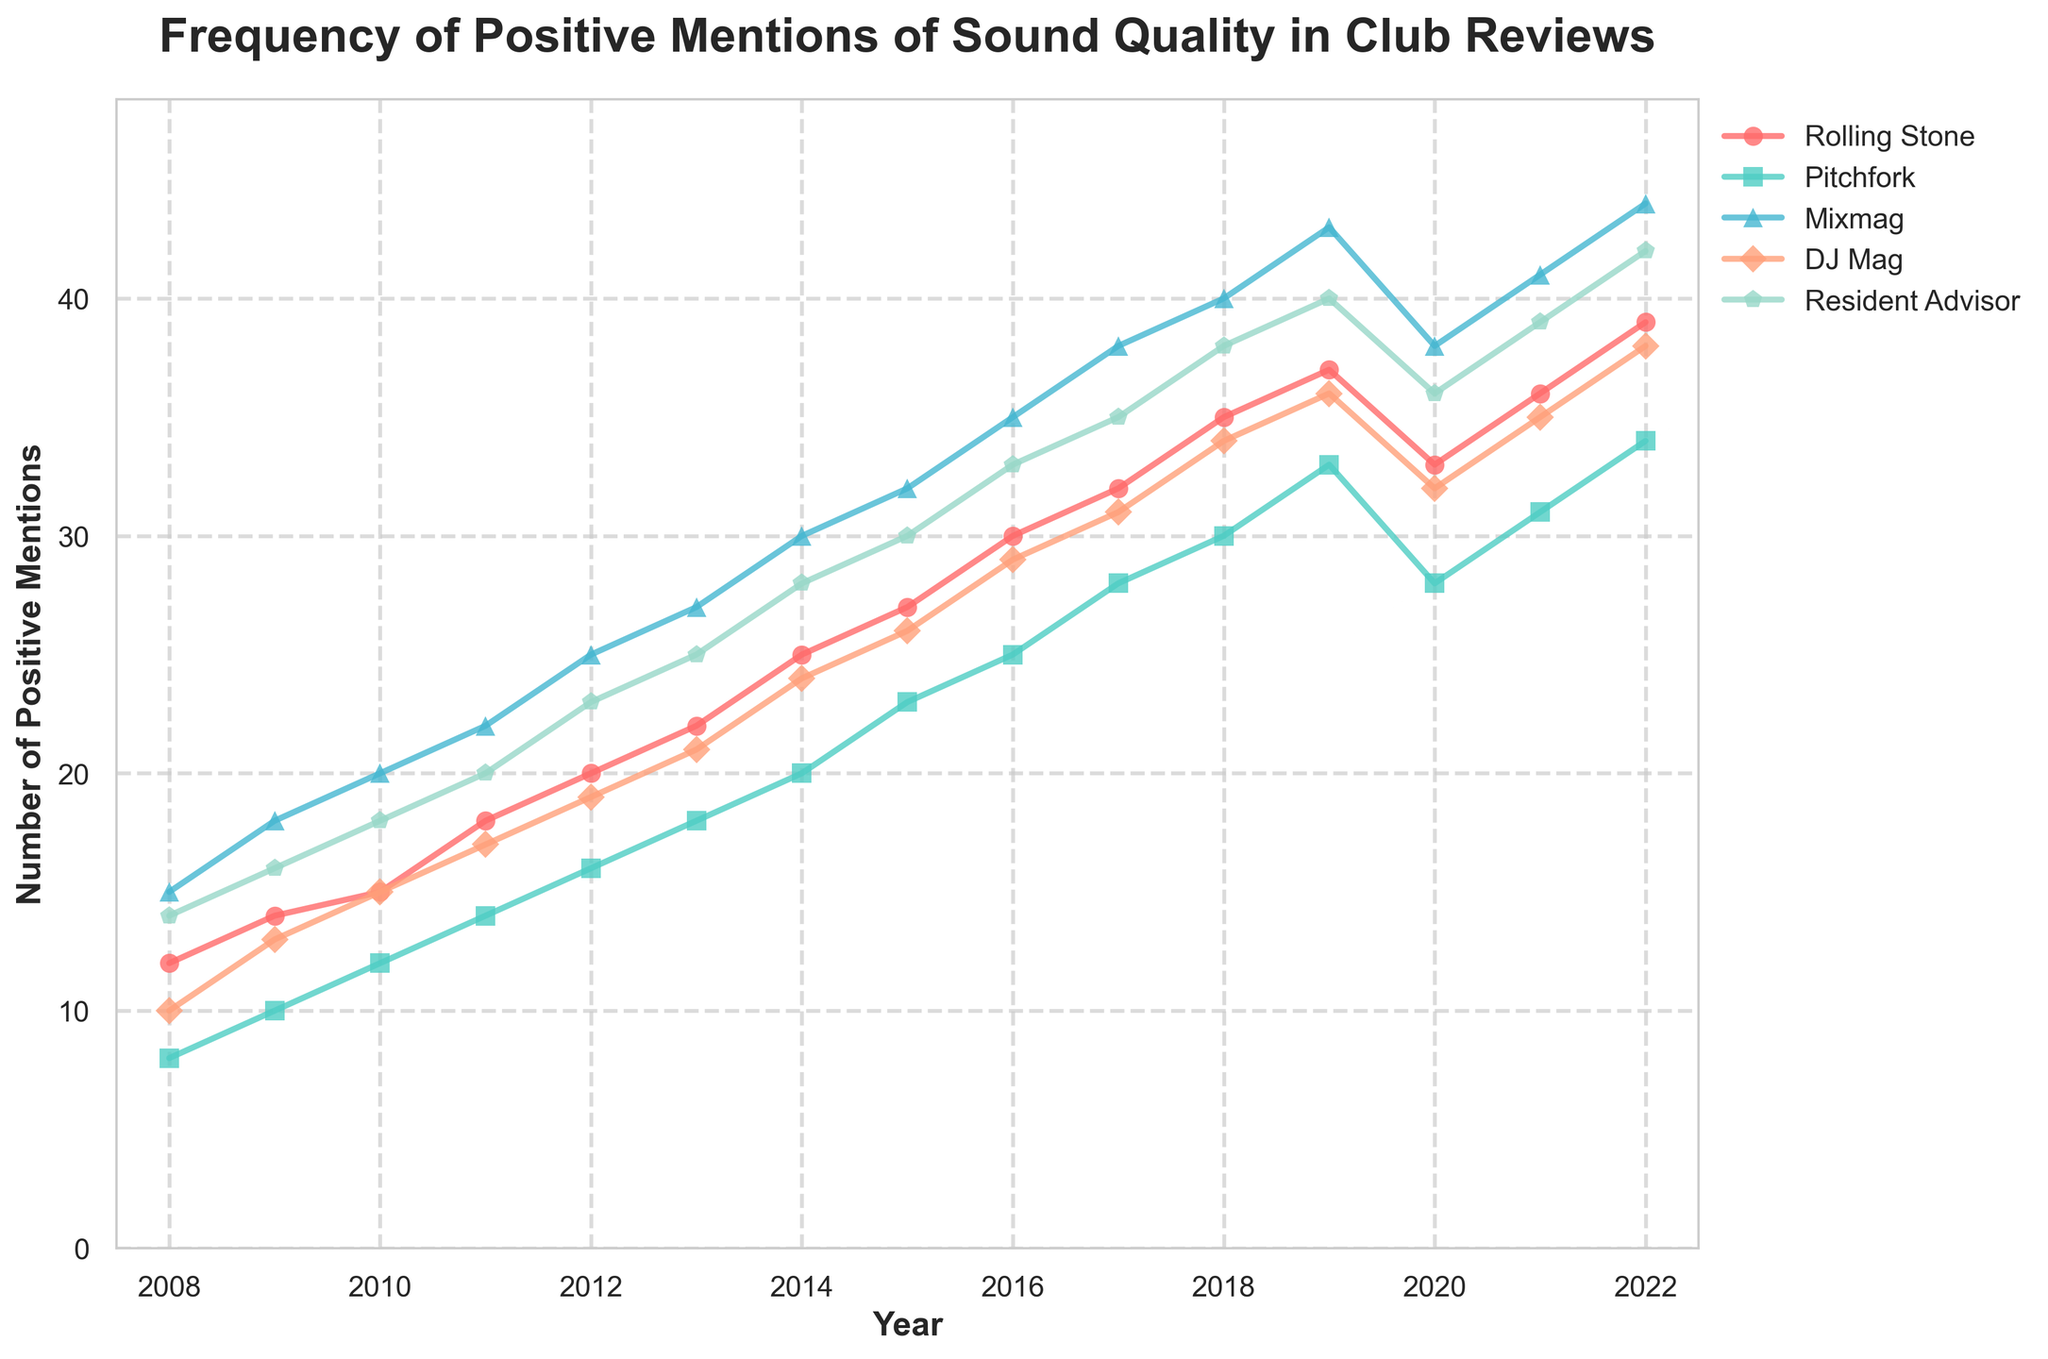What year did Rolling Stone have its highest frequency of positive mentions? Rolling Stone shows the highest frequency in the year 2022. The line representing Rolling Stone peaks here.
Answer: 2022 Which publication consistently had the highest number of positive mentions since 2008? Mixmag consistently had the highest number of positive mentions, as indicated by the Mixmag line always being above the others.
Answer: Mixmag By how much did Pitchfork's positive mentions increase from 2008 to 2015? In 2008, Pitchfork had 8 mentions and in 2015 it had 23. The increase is 23 - 8 = 15 mentions.
Answer: 15 Which publication experienced a decline in positive mentions from 2019 to 2020? The publication experiencing a decline is Rolling Stone, as its mentions dropped from 37 in 2019 to 33 in 2020.
Answer: Rolling Stone What is the difference between the highest and lowest number of positive mentions for DJ Mag in 2022? DJ Mag has 38 mentions in 2022, and among the five publications, the lowest for that year is Pitchfork with 34 mentions. The difference is 38 - 34 = 4.
Answer: 4 How did the number of positive mentions for Resident Advisor change from 2017 to 2022? Resident Advisor mentions increased from 35 in 2017 to 42 in 2022. The change is 42 - 35 = 7 mentions.
Answer: 7 Which two publications' lines intersect between the years 2020 and 2021? The two intersecting lines are Rolling Stone and Resident Advisor, where they both have 36 mentions in 2021.
Answer: Rolling Stone and Resident Advisor What was the total number of positive mentions for all publications in 2013? Summing the mentions for 2013: Rolling Stone (22) + Pitchfork (18) + Mixmag (27) + DJ Mag (21) + Resident Advisor (25) = 113.
Answer: 113 Between 2010 and 2015, which publication showed the most significant increase in positive mentions? Mixmag showed the most significant increase as it went from 20 in 2010 to 32 in 2015, which is an increase of 32 - 20 = 12 mentions.
Answer: Mixmag Which publication's trend appears the most consistent (least fluctuations) over the 15-year period? Resident Advisor shows the most consistent increase, with fewer and smaller fluctuations compared to others.
Answer: Resident Advisor 